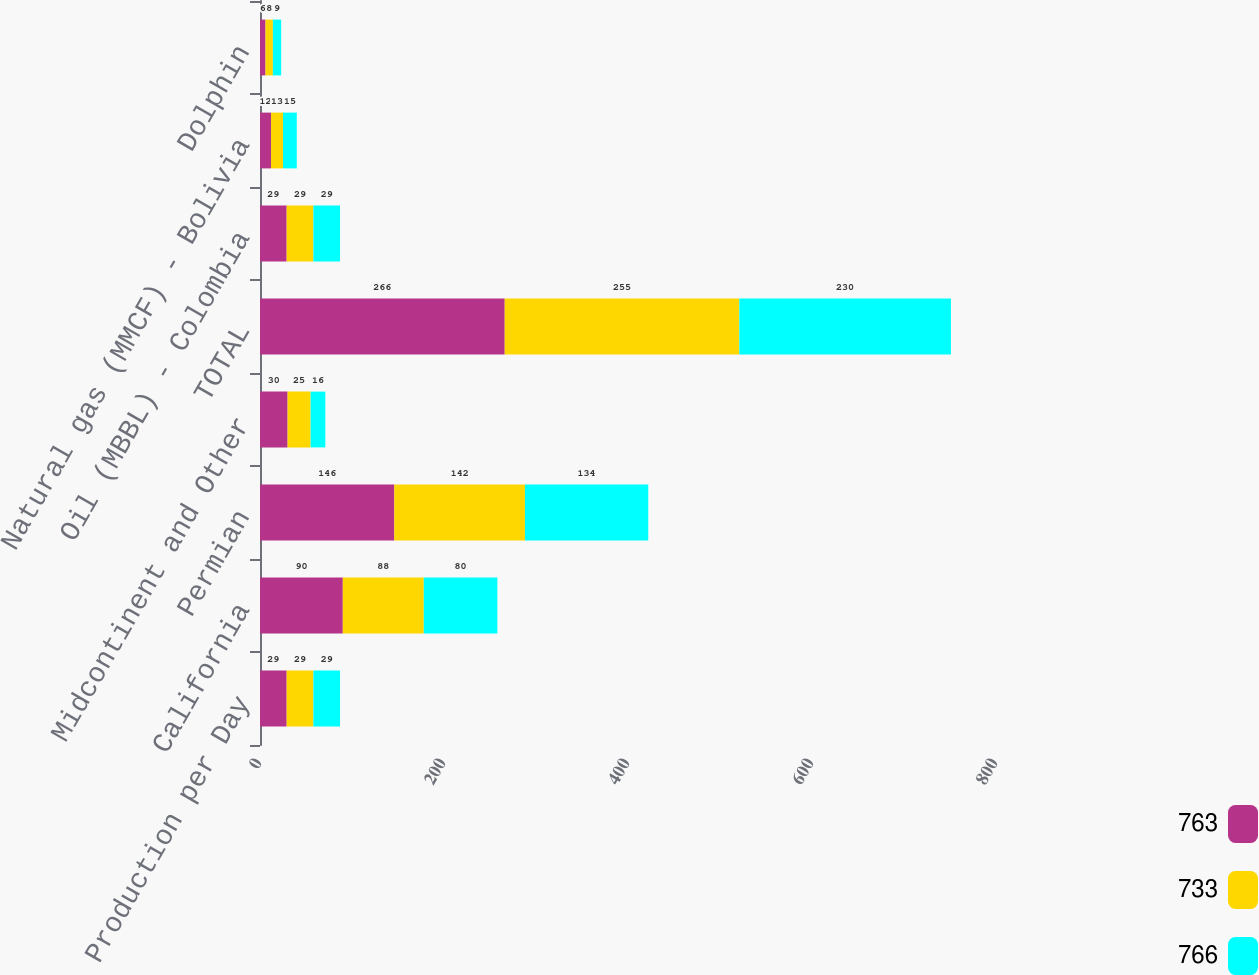<chart> <loc_0><loc_0><loc_500><loc_500><stacked_bar_chart><ecel><fcel>Production per Day<fcel>California<fcel>Permian<fcel>Midcontinent and Other<fcel>TOTAL<fcel>Oil (MBBL) - Colombia<fcel>Natural gas (MMCF) - Bolivia<fcel>Dolphin<nl><fcel>763<fcel>29<fcel>90<fcel>146<fcel>30<fcel>266<fcel>29<fcel>12<fcel>6<nl><fcel>733<fcel>29<fcel>88<fcel>142<fcel>25<fcel>255<fcel>29<fcel>13<fcel>8<nl><fcel>766<fcel>29<fcel>80<fcel>134<fcel>16<fcel>230<fcel>29<fcel>15<fcel>9<nl></chart> 